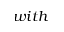<formula> <loc_0><loc_0><loc_500><loc_500>w i t h</formula> 